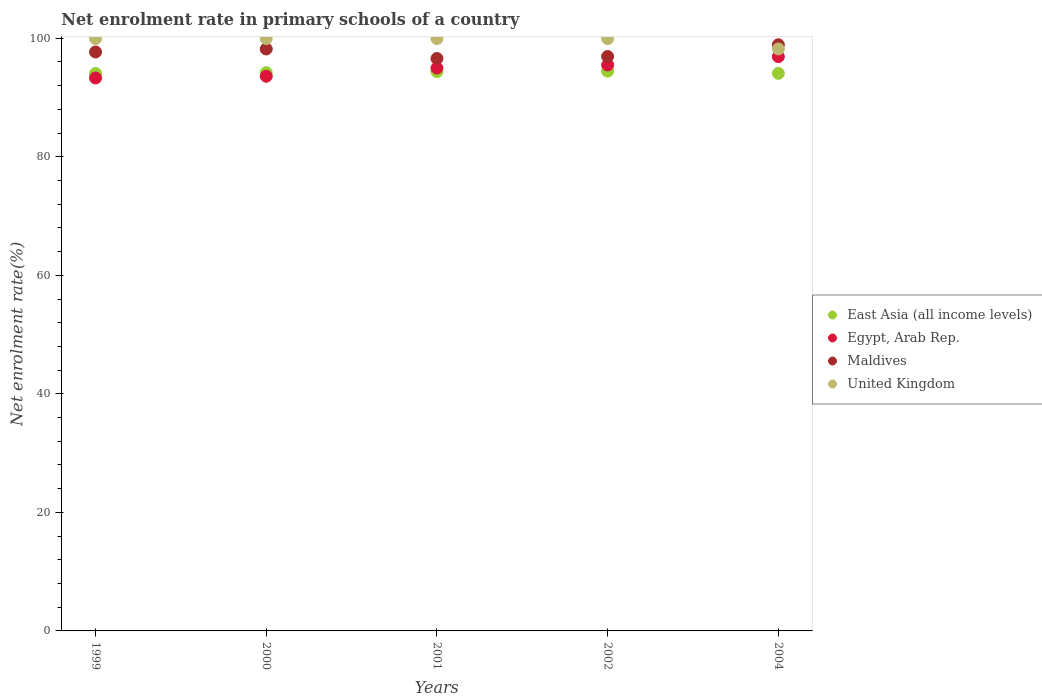Is the number of dotlines equal to the number of legend labels?
Provide a short and direct response. Yes. What is the net enrolment rate in primary schools in East Asia (all income levels) in 2000?
Keep it short and to the point. 94.19. Across all years, what is the maximum net enrolment rate in primary schools in Egypt, Arab Rep.?
Make the answer very short. 96.9. Across all years, what is the minimum net enrolment rate in primary schools in Egypt, Arab Rep.?
Your answer should be compact. 93.3. In which year was the net enrolment rate in primary schools in East Asia (all income levels) minimum?
Ensure brevity in your answer.  1999. What is the total net enrolment rate in primary schools in Egypt, Arab Rep. in the graph?
Ensure brevity in your answer.  474.25. What is the difference between the net enrolment rate in primary schools in Egypt, Arab Rep. in 1999 and that in 2001?
Your answer should be very brief. -1.68. What is the difference between the net enrolment rate in primary schools in United Kingdom in 2004 and the net enrolment rate in primary schools in Egypt, Arab Rep. in 2000?
Ensure brevity in your answer.  4.61. What is the average net enrolment rate in primary schools in Egypt, Arab Rep. per year?
Your answer should be compact. 94.85. In the year 2004, what is the difference between the net enrolment rate in primary schools in Maldives and net enrolment rate in primary schools in Egypt, Arab Rep.?
Provide a succinct answer. 2.01. What is the ratio of the net enrolment rate in primary schools in Maldives in 2000 to that in 2002?
Your answer should be very brief. 1.01. Is the net enrolment rate in primary schools in East Asia (all income levels) in 2000 less than that in 2001?
Ensure brevity in your answer.  Yes. Is the difference between the net enrolment rate in primary schools in Maldives in 1999 and 2002 greater than the difference between the net enrolment rate in primary schools in Egypt, Arab Rep. in 1999 and 2002?
Give a very brief answer. Yes. What is the difference between the highest and the second highest net enrolment rate in primary schools in Maldives?
Keep it short and to the point. 0.71. What is the difference between the highest and the lowest net enrolment rate in primary schools in Maldives?
Make the answer very short. 2.32. In how many years, is the net enrolment rate in primary schools in East Asia (all income levels) greater than the average net enrolment rate in primary schools in East Asia (all income levels) taken over all years?
Your answer should be compact. 2. Is the sum of the net enrolment rate in primary schools in Maldives in 1999 and 2004 greater than the maximum net enrolment rate in primary schools in Egypt, Arab Rep. across all years?
Your answer should be very brief. Yes. Is it the case that in every year, the sum of the net enrolment rate in primary schools in Egypt, Arab Rep. and net enrolment rate in primary schools in East Asia (all income levels)  is greater than the sum of net enrolment rate in primary schools in Maldives and net enrolment rate in primary schools in United Kingdom?
Offer a very short reply. No. Does the net enrolment rate in primary schools in United Kingdom monotonically increase over the years?
Your answer should be compact. No. What is the difference between two consecutive major ticks on the Y-axis?
Give a very brief answer. 20. Are the values on the major ticks of Y-axis written in scientific E-notation?
Provide a short and direct response. No. Where does the legend appear in the graph?
Your response must be concise. Center right. How many legend labels are there?
Your response must be concise. 4. What is the title of the graph?
Offer a very short reply. Net enrolment rate in primary schools of a country. What is the label or title of the X-axis?
Ensure brevity in your answer.  Years. What is the label or title of the Y-axis?
Provide a succinct answer. Net enrolment rate(%). What is the Net enrolment rate(%) of East Asia (all income levels) in 1999?
Offer a terse response. 94.06. What is the Net enrolment rate(%) of Egypt, Arab Rep. in 1999?
Your response must be concise. 93.3. What is the Net enrolment rate(%) of Maldives in 1999?
Your answer should be compact. 97.69. What is the Net enrolment rate(%) in United Kingdom in 1999?
Offer a terse response. 99.95. What is the Net enrolment rate(%) of East Asia (all income levels) in 2000?
Provide a succinct answer. 94.19. What is the Net enrolment rate(%) of Egypt, Arab Rep. in 2000?
Provide a short and direct response. 93.59. What is the Net enrolment rate(%) in Maldives in 2000?
Your answer should be very brief. 98.19. What is the Net enrolment rate(%) of United Kingdom in 2000?
Offer a terse response. 99.95. What is the Net enrolment rate(%) of East Asia (all income levels) in 2001?
Provide a short and direct response. 94.38. What is the Net enrolment rate(%) in Egypt, Arab Rep. in 2001?
Your response must be concise. 94.98. What is the Net enrolment rate(%) in Maldives in 2001?
Your answer should be compact. 96.58. What is the Net enrolment rate(%) of United Kingdom in 2001?
Keep it short and to the point. 99.94. What is the Net enrolment rate(%) in East Asia (all income levels) in 2002?
Offer a terse response. 94.44. What is the Net enrolment rate(%) in Egypt, Arab Rep. in 2002?
Keep it short and to the point. 95.49. What is the Net enrolment rate(%) of Maldives in 2002?
Provide a short and direct response. 96.92. What is the Net enrolment rate(%) of United Kingdom in 2002?
Your answer should be very brief. 99.94. What is the Net enrolment rate(%) in East Asia (all income levels) in 2004?
Your answer should be compact. 94.08. What is the Net enrolment rate(%) in Egypt, Arab Rep. in 2004?
Ensure brevity in your answer.  96.9. What is the Net enrolment rate(%) in Maldives in 2004?
Your answer should be very brief. 98.9. What is the Net enrolment rate(%) of United Kingdom in 2004?
Provide a short and direct response. 98.2. Across all years, what is the maximum Net enrolment rate(%) in East Asia (all income levels)?
Provide a succinct answer. 94.44. Across all years, what is the maximum Net enrolment rate(%) of Egypt, Arab Rep.?
Your answer should be very brief. 96.9. Across all years, what is the maximum Net enrolment rate(%) in Maldives?
Offer a terse response. 98.9. Across all years, what is the maximum Net enrolment rate(%) in United Kingdom?
Provide a succinct answer. 99.95. Across all years, what is the minimum Net enrolment rate(%) of East Asia (all income levels)?
Offer a very short reply. 94.06. Across all years, what is the minimum Net enrolment rate(%) in Egypt, Arab Rep.?
Your answer should be very brief. 93.3. Across all years, what is the minimum Net enrolment rate(%) of Maldives?
Keep it short and to the point. 96.58. Across all years, what is the minimum Net enrolment rate(%) of United Kingdom?
Your answer should be very brief. 98.2. What is the total Net enrolment rate(%) in East Asia (all income levels) in the graph?
Give a very brief answer. 471.15. What is the total Net enrolment rate(%) of Egypt, Arab Rep. in the graph?
Your answer should be compact. 474.25. What is the total Net enrolment rate(%) of Maldives in the graph?
Your response must be concise. 488.28. What is the total Net enrolment rate(%) in United Kingdom in the graph?
Offer a terse response. 497.99. What is the difference between the Net enrolment rate(%) in East Asia (all income levels) in 1999 and that in 2000?
Offer a terse response. -0.14. What is the difference between the Net enrolment rate(%) in Egypt, Arab Rep. in 1999 and that in 2000?
Provide a succinct answer. -0.3. What is the difference between the Net enrolment rate(%) in Maldives in 1999 and that in 2000?
Your answer should be compact. -0.5. What is the difference between the Net enrolment rate(%) in United Kingdom in 1999 and that in 2000?
Ensure brevity in your answer.  -0. What is the difference between the Net enrolment rate(%) in East Asia (all income levels) in 1999 and that in 2001?
Keep it short and to the point. -0.33. What is the difference between the Net enrolment rate(%) of Egypt, Arab Rep. in 1999 and that in 2001?
Keep it short and to the point. -1.68. What is the difference between the Net enrolment rate(%) in Maldives in 1999 and that in 2001?
Give a very brief answer. 1.11. What is the difference between the Net enrolment rate(%) of United Kingdom in 1999 and that in 2001?
Ensure brevity in your answer.  0. What is the difference between the Net enrolment rate(%) in East Asia (all income levels) in 1999 and that in 2002?
Ensure brevity in your answer.  -0.38. What is the difference between the Net enrolment rate(%) of Egypt, Arab Rep. in 1999 and that in 2002?
Provide a succinct answer. -2.2. What is the difference between the Net enrolment rate(%) of Maldives in 1999 and that in 2002?
Ensure brevity in your answer.  0.76. What is the difference between the Net enrolment rate(%) in United Kingdom in 1999 and that in 2002?
Keep it short and to the point. 0.01. What is the difference between the Net enrolment rate(%) of East Asia (all income levels) in 1999 and that in 2004?
Your answer should be very brief. -0.02. What is the difference between the Net enrolment rate(%) of Egypt, Arab Rep. in 1999 and that in 2004?
Your response must be concise. -3.6. What is the difference between the Net enrolment rate(%) in Maldives in 1999 and that in 2004?
Your answer should be very brief. -1.21. What is the difference between the Net enrolment rate(%) in United Kingdom in 1999 and that in 2004?
Provide a succinct answer. 1.75. What is the difference between the Net enrolment rate(%) of East Asia (all income levels) in 2000 and that in 2001?
Offer a very short reply. -0.19. What is the difference between the Net enrolment rate(%) in Egypt, Arab Rep. in 2000 and that in 2001?
Provide a succinct answer. -1.39. What is the difference between the Net enrolment rate(%) of Maldives in 2000 and that in 2001?
Give a very brief answer. 1.61. What is the difference between the Net enrolment rate(%) in United Kingdom in 2000 and that in 2001?
Offer a very short reply. 0.01. What is the difference between the Net enrolment rate(%) in East Asia (all income levels) in 2000 and that in 2002?
Make the answer very short. -0.25. What is the difference between the Net enrolment rate(%) in Egypt, Arab Rep. in 2000 and that in 2002?
Offer a very short reply. -1.9. What is the difference between the Net enrolment rate(%) in Maldives in 2000 and that in 2002?
Your answer should be compact. 1.26. What is the difference between the Net enrolment rate(%) in United Kingdom in 2000 and that in 2002?
Provide a short and direct response. 0.01. What is the difference between the Net enrolment rate(%) of East Asia (all income levels) in 2000 and that in 2004?
Offer a terse response. 0.12. What is the difference between the Net enrolment rate(%) in Egypt, Arab Rep. in 2000 and that in 2004?
Provide a succinct answer. -3.31. What is the difference between the Net enrolment rate(%) in Maldives in 2000 and that in 2004?
Keep it short and to the point. -0.71. What is the difference between the Net enrolment rate(%) of United Kingdom in 2000 and that in 2004?
Make the answer very short. 1.75. What is the difference between the Net enrolment rate(%) of East Asia (all income levels) in 2001 and that in 2002?
Offer a terse response. -0.06. What is the difference between the Net enrolment rate(%) in Egypt, Arab Rep. in 2001 and that in 2002?
Provide a succinct answer. -0.52. What is the difference between the Net enrolment rate(%) in Maldives in 2001 and that in 2002?
Ensure brevity in your answer.  -0.34. What is the difference between the Net enrolment rate(%) of United Kingdom in 2001 and that in 2002?
Your answer should be very brief. 0. What is the difference between the Net enrolment rate(%) in East Asia (all income levels) in 2001 and that in 2004?
Ensure brevity in your answer.  0.31. What is the difference between the Net enrolment rate(%) in Egypt, Arab Rep. in 2001 and that in 2004?
Make the answer very short. -1.92. What is the difference between the Net enrolment rate(%) in Maldives in 2001 and that in 2004?
Make the answer very short. -2.32. What is the difference between the Net enrolment rate(%) in United Kingdom in 2001 and that in 2004?
Offer a terse response. 1.74. What is the difference between the Net enrolment rate(%) in East Asia (all income levels) in 2002 and that in 2004?
Ensure brevity in your answer.  0.36. What is the difference between the Net enrolment rate(%) of Egypt, Arab Rep. in 2002 and that in 2004?
Your answer should be very brief. -1.4. What is the difference between the Net enrolment rate(%) of Maldives in 2002 and that in 2004?
Your response must be concise. -1.98. What is the difference between the Net enrolment rate(%) in United Kingdom in 2002 and that in 2004?
Provide a short and direct response. 1.74. What is the difference between the Net enrolment rate(%) in East Asia (all income levels) in 1999 and the Net enrolment rate(%) in Egypt, Arab Rep. in 2000?
Your response must be concise. 0.46. What is the difference between the Net enrolment rate(%) of East Asia (all income levels) in 1999 and the Net enrolment rate(%) of Maldives in 2000?
Your answer should be very brief. -4.13. What is the difference between the Net enrolment rate(%) in East Asia (all income levels) in 1999 and the Net enrolment rate(%) in United Kingdom in 2000?
Offer a terse response. -5.9. What is the difference between the Net enrolment rate(%) of Egypt, Arab Rep. in 1999 and the Net enrolment rate(%) of Maldives in 2000?
Keep it short and to the point. -4.89. What is the difference between the Net enrolment rate(%) in Egypt, Arab Rep. in 1999 and the Net enrolment rate(%) in United Kingdom in 2000?
Keep it short and to the point. -6.66. What is the difference between the Net enrolment rate(%) of Maldives in 1999 and the Net enrolment rate(%) of United Kingdom in 2000?
Offer a very short reply. -2.26. What is the difference between the Net enrolment rate(%) in East Asia (all income levels) in 1999 and the Net enrolment rate(%) in Egypt, Arab Rep. in 2001?
Provide a short and direct response. -0.92. What is the difference between the Net enrolment rate(%) in East Asia (all income levels) in 1999 and the Net enrolment rate(%) in Maldives in 2001?
Provide a succinct answer. -2.53. What is the difference between the Net enrolment rate(%) in East Asia (all income levels) in 1999 and the Net enrolment rate(%) in United Kingdom in 2001?
Provide a succinct answer. -5.89. What is the difference between the Net enrolment rate(%) of Egypt, Arab Rep. in 1999 and the Net enrolment rate(%) of Maldives in 2001?
Offer a very short reply. -3.29. What is the difference between the Net enrolment rate(%) of Egypt, Arab Rep. in 1999 and the Net enrolment rate(%) of United Kingdom in 2001?
Offer a terse response. -6.65. What is the difference between the Net enrolment rate(%) in Maldives in 1999 and the Net enrolment rate(%) in United Kingdom in 2001?
Provide a short and direct response. -2.26. What is the difference between the Net enrolment rate(%) of East Asia (all income levels) in 1999 and the Net enrolment rate(%) of Egypt, Arab Rep. in 2002?
Keep it short and to the point. -1.44. What is the difference between the Net enrolment rate(%) of East Asia (all income levels) in 1999 and the Net enrolment rate(%) of Maldives in 2002?
Your answer should be compact. -2.87. What is the difference between the Net enrolment rate(%) of East Asia (all income levels) in 1999 and the Net enrolment rate(%) of United Kingdom in 2002?
Ensure brevity in your answer.  -5.89. What is the difference between the Net enrolment rate(%) in Egypt, Arab Rep. in 1999 and the Net enrolment rate(%) in Maldives in 2002?
Offer a very short reply. -3.63. What is the difference between the Net enrolment rate(%) in Egypt, Arab Rep. in 1999 and the Net enrolment rate(%) in United Kingdom in 2002?
Provide a succinct answer. -6.65. What is the difference between the Net enrolment rate(%) of Maldives in 1999 and the Net enrolment rate(%) of United Kingdom in 2002?
Offer a terse response. -2.25. What is the difference between the Net enrolment rate(%) in East Asia (all income levels) in 1999 and the Net enrolment rate(%) in Egypt, Arab Rep. in 2004?
Keep it short and to the point. -2.84. What is the difference between the Net enrolment rate(%) of East Asia (all income levels) in 1999 and the Net enrolment rate(%) of Maldives in 2004?
Your answer should be compact. -4.85. What is the difference between the Net enrolment rate(%) in East Asia (all income levels) in 1999 and the Net enrolment rate(%) in United Kingdom in 2004?
Make the answer very short. -4.14. What is the difference between the Net enrolment rate(%) of Egypt, Arab Rep. in 1999 and the Net enrolment rate(%) of Maldives in 2004?
Offer a very short reply. -5.61. What is the difference between the Net enrolment rate(%) of Egypt, Arab Rep. in 1999 and the Net enrolment rate(%) of United Kingdom in 2004?
Your answer should be very brief. -4.9. What is the difference between the Net enrolment rate(%) in Maldives in 1999 and the Net enrolment rate(%) in United Kingdom in 2004?
Your response must be concise. -0.51. What is the difference between the Net enrolment rate(%) in East Asia (all income levels) in 2000 and the Net enrolment rate(%) in Egypt, Arab Rep. in 2001?
Keep it short and to the point. -0.78. What is the difference between the Net enrolment rate(%) of East Asia (all income levels) in 2000 and the Net enrolment rate(%) of Maldives in 2001?
Offer a terse response. -2.39. What is the difference between the Net enrolment rate(%) of East Asia (all income levels) in 2000 and the Net enrolment rate(%) of United Kingdom in 2001?
Offer a terse response. -5.75. What is the difference between the Net enrolment rate(%) of Egypt, Arab Rep. in 2000 and the Net enrolment rate(%) of Maldives in 2001?
Your response must be concise. -2.99. What is the difference between the Net enrolment rate(%) in Egypt, Arab Rep. in 2000 and the Net enrolment rate(%) in United Kingdom in 2001?
Your answer should be compact. -6.35. What is the difference between the Net enrolment rate(%) of Maldives in 2000 and the Net enrolment rate(%) of United Kingdom in 2001?
Provide a succinct answer. -1.76. What is the difference between the Net enrolment rate(%) of East Asia (all income levels) in 2000 and the Net enrolment rate(%) of Egypt, Arab Rep. in 2002?
Offer a very short reply. -1.3. What is the difference between the Net enrolment rate(%) in East Asia (all income levels) in 2000 and the Net enrolment rate(%) in Maldives in 2002?
Ensure brevity in your answer.  -2.73. What is the difference between the Net enrolment rate(%) in East Asia (all income levels) in 2000 and the Net enrolment rate(%) in United Kingdom in 2002?
Provide a short and direct response. -5.75. What is the difference between the Net enrolment rate(%) in Egypt, Arab Rep. in 2000 and the Net enrolment rate(%) in Maldives in 2002?
Offer a terse response. -3.33. What is the difference between the Net enrolment rate(%) in Egypt, Arab Rep. in 2000 and the Net enrolment rate(%) in United Kingdom in 2002?
Make the answer very short. -6.35. What is the difference between the Net enrolment rate(%) in Maldives in 2000 and the Net enrolment rate(%) in United Kingdom in 2002?
Make the answer very short. -1.76. What is the difference between the Net enrolment rate(%) in East Asia (all income levels) in 2000 and the Net enrolment rate(%) in Egypt, Arab Rep. in 2004?
Ensure brevity in your answer.  -2.7. What is the difference between the Net enrolment rate(%) in East Asia (all income levels) in 2000 and the Net enrolment rate(%) in Maldives in 2004?
Your answer should be compact. -4.71. What is the difference between the Net enrolment rate(%) in East Asia (all income levels) in 2000 and the Net enrolment rate(%) in United Kingdom in 2004?
Provide a short and direct response. -4.01. What is the difference between the Net enrolment rate(%) of Egypt, Arab Rep. in 2000 and the Net enrolment rate(%) of Maldives in 2004?
Your answer should be very brief. -5.31. What is the difference between the Net enrolment rate(%) of Egypt, Arab Rep. in 2000 and the Net enrolment rate(%) of United Kingdom in 2004?
Provide a succinct answer. -4.61. What is the difference between the Net enrolment rate(%) of Maldives in 2000 and the Net enrolment rate(%) of United Kingdom in 2004?
Your response must be concise. -0.01. What is the difference between the Net enrolment rate(%) of East Asia (all income levels) in 2001 and the Net enrolment rate(%) of Egypt, Arab Rep. in 2002?
Make the answer very short. -1.11. What is the difference between the Net enrolment rate(%) in East Asia (all income levels) in 2001 and the Net enrolment rate(%) in Maldives in 2002?
Your answer should be very brief. -2.54. What is the difference between the Net enrolment rate(%) of East Asia (all income levels) in 2001 and the Net enrolment rate(%) of United Kingdom in 2002?
Provide a succinct answer. -5.56. What is the difference between the Net enrolment rate(%) in Egypt, Arab Rep. in 2001 and the Net enrolment rate(%) in Maldives in 2002?
Offer a terse response. -1.95. What is the difference between the Net enrolment rate(%) of Egypt, Arab Rep. in 2001 and the Net enrolment rate(%) of United Kingdom in 2002?
Provide a short and direct response. -4.97. What is the difference between the Net enrolment rate(%) of Maldives in 2001 and the Net enrolment rate(%) of United Kingdom in 2002?
Offer a terse response. -3.36. What is the difference between the Net enrolment rate(%) in East Asia (all income levels) in 2001 and the Net enrolment rate(%) in Egypt, Arab Rep. in 2004?
Ensure brevity in your answer.  -2.52. What is the difference between the Net enrolment rate(%) in East Asia (all income levels) in 2001 and the Net enrolment rate(%) in Maldives in 2004?
Offer a very short reply. -4.52. What is the difference between the Net enrolment rate(%) in East Asia (all income levels) in 2001 and the Net enrolment rate(%) in United Kingdom in 2004?
Provide a succinct answer. -3.82. What is the difference between the Net enrolment rate(%) of Egypt, Arab Rep. in 2001 and the Net enrolment rate(%) of Maldives in 2004?
Offer a very short reply. -3.93. What is the difference between the Net enrolment rate(%) in Egypt, Arab Rep. in 2001 and the Net enrolment rate(%) in United Kingdom in 2004?
Give a very brief answer. -3.22. What is the difference between the Net enrolment rate(%) in Maldives in 2001 and the Net enrolment rate(%) in United Kingdom in 2004?
Give a very brief answer. -1.62. What is the difference between the Net enrolment rate(%) of East Asia (all income levels) in 2002 and the Net enrolment rate(%) of Egypt, Arab Rep. in 2004?
Your answer should be very brief. -2.46. What is the difference between the Net enrolment rate(%) in East Asia (all income levels) in 2002 and the Net enrolment rate(%) in Maldives in 2004?
Your answer should be compact. -4.46. What is the difference between the Net enrolment rate(%) of East Asia (all income levels) in 2002 and the Net enrolment rate(%) of United Kingdom in 2004?
Your answer should be compact. -3.76. What is the difference between the Net enrolment rate(%) in Egypt, Arab Rep. in 2002 and the Net enrolment rate(%) in Maldives in 2004?
Your response must be concise. -3.41. What is the difference between the Net enrolment rate(%) of Egypt, Arab Rep. in 2002 and the Net enrolment rate(%) of United Kingdom in 2004?
Ensure brevity in your answer.  -2.71. What is the difference between the Net enrolment rate(%) of Maldives in 2002 and the Net enrolment rate(%) of United Kingdom in 2004?
Provide a short and direct response. -1.28. What is the average Net enrolment rate(%) of East Asia (all income levels) per year?
Your answer should be very brief. 94.23. What is the average Net enrolment rate(%) in Egypt, Arab Rep. per year?
Your answer should be very brief. 94.85. What is the average Net enrolment rate(%) of Maldives per year?
Ensure brevity in your answer.  97.66. What is the average Net enrolment rate(%) in United Kingdom per year?
Give a very brief answer. 99.6. In the year 1999, what is the difference between the Net enrolment rate(%) of East Asia (all income levels) and Net enrolment rate(%) of Egypt, Arab Rep.?
Give a very brief answer. 0.76. In the year 1999, what is the difference between the Net enrolment rate(%) in East Asia (all income levels) and Net enrolment rate(%) in Maldives?
Provide a succinct answer. -3.63. In the year 1999, what is the difference between the Net enrolment rate(%) of East Asia (all income levels) and Net enrolment rate(%) of United Kingdom?
Ensure brevity in your answer.  -5.89. In the year 1999, what is the difference between the Net enrolment rate(%) of Egypt, Arab Rep. and Net enrolment rate(%) of Maldives?
Keep it short and to the point. -4.39. In the year 1999, what is the difference between the Net enrolment rate(%) of Egypt, Arab Rep. and Net enrolment rate(%) of United Kingdom?
Your answer should be compact. -6.65. In the year 1999, what is the difference between the Net enrolment rate(%) in Maldives and Net enrolment rate(%) in United Kingdom?
Your answer should be very brief. -2.26. In the year 2000, what is the difference between the Net enrolment rate(%) in East Asia (all income levels) and Net enrolment rate(%) in Egypt, Arab Rep.?
Provide a short and direct response. 0.6. In the year 2000, what is the difference between the Net enrolment rate(%) in East Asia (all income levels) and Net enrolment rate(%) in Maldives?
Offer a very short reply. -3.99. In the year 2000, what is the difference between the Net enrolment rate(%) of East Asia (all income levels) and Net enrolment rate(%) of United Kingdom?
Ensure brevity in your answer.  -5.76. In the year 2000, what is the difference between the Net enrolment rate(%) in Egypt, Arab Rep. and Net enrolment rate(%) in Maldives?
Your answer should be compact. -4.6. In the year 2000, what is the difference between the Net enrolment rate(%) of Egypt, Arab Rep. and Net enrolment rate(%) of United Kingdom?
Make the answer very short. -6.36. In the year 2000, what is the difference between the Net enrolment rate(%) of Maldives and Net enrolment rate(%) of United Kingdom?
Offer a terse response. -1.76. In the year 2001, what is the difference between the Net enrolment rate(%) in East Asia (all income levels) and Net enrolment rate(%) in Egypt, Arab Rep.?
Keep it short and to the point. -0.59. In the year 2001, what is the difference between the Net enrolment rate(%) of East Asia (all income levels) and Net enrolment rate(%) of Maldives?
Make the answer very short. -2.2. In the year 2001, what is the difference between the Net enrolment rate(%) of East Asia (all income levels) and Net enrolment rate(%) of United Kingdom?
Your response must be concise. -5.56. In the year 2001, what is the difference between the Net enrolment rate(%) in Egypt, Arab Rep. and Net enrolment rate(%) in Maldives?
Provide a succinct answer. -1.61. In the year 2001, what is the difference between the Net enrolment rate(%) in Egypt, Arab Rep. and Net enrolment rate(%) in United Kingdom?
Your answer should be very brief. -4.97. In the year 2001, what is the difference between the Net enrolment rate(%) in Maldives and Net enrolment rate(%) in United Kingdom?
Your response must be concise. -3.36. In the year 2002, what is the difference between the Net enrolment rate(%) in East Asia (all income levels) and Net enrolment rate(%) in Egypt, Arab Rep.?
Ensure brevity in your answer.  -1.05. In the year 2002, what is the difference between the Net enrolment rate(%) in East Asia (all income levels) and Net enrolment rate(%) in Maldives?
Give a very brief answer. -2.48. In the year 2002, what is the difference between the Net enrolment rate(%) in East Asia (all income levels) and Net enrolment rate(%) in United Kingdom?
Ensure brevity in your answer.  -5.5. In the year 2002, what is the difference between the Net enrolment rate(%) of Egypt, Arab Rep. and Net enrolment rate(%) of Maldives?
Provide a succinct answer. -1.43. In the year 2002, what is the difference between the Net enrolment rate(%) in Egypt, Arab Rep. and Net enrolment rate(%) in United Kingdom?
Your response must be concise. -4.45. In the year 2002, what is the difference between the Net enrolment rate(%) of Maldives and Net enrolment rate(%) of United Kingdom?
Your answer should be very brief. -3.02. In the year 2004, what is the difference between the Net enrolment rate(%) of East Asia (all income levels) and Net enrolment rate(%) of Egypt, Arab Rep.?
Ensure brevity in your answer.  -2.82. In the year 2004, what is the difference between the Net enrolment rate(%) in East Asia (all income levels) and Net enrolment rate(%) in Maldives?
Provide a succinct answer. -4.83. In the year 2004, what is the difference between the Net enrolment rate(%) of East Asia (all income levels) and Net enrolment rate(%) of United Kingdom?
Keep it short and to the point. -4.12. In the year 2004, what is the difference between the Net enrolment rate(%) of Egypt, Arab Rep. and Net enrolment rate(%) of Maldives?
Give a very brief answer. -2.01. In the year 2004, what is the difference between the Net enrolment rate(%) of Egypt, Arab Rep. and Net enrolment rate(%) of United Kingdom?
Provide a short and direct response. -1.3. In the year 2004, what is the difference between the Net enrolment rate(%) in Maldives and Net enrolment rate(%) in United Kingdom?
Offer a terse response. 0.7. What is the ratio of the Net enrolment rate(%) of East Asia (all income levels) in 1999 to that in 2001?
Keep it short and to the point. 1. What is the ratio of the Net enrolment rate(%) of Egypt, Arab Rep. in 1999 to that in 2001?
Offer a very short reply. 0.98. What is the ratio of the Net enrolment rate(%) of Maldives in 1999 to that in 2001?
Provide a succinct answer. 1.01. What is the ratio of the Net enrolment rate(%) of United Kingdom in 1999 to that in 2001?
Offer a very short reply. 1. What is the ratio of the Net enrolment rate(%) in East Asia (all income levels) in 1999 to that in 2002?
Provide a succinct answer. 1. What is the ratio of the Net enrolment rate(%) of Maldives in 1999 to that in 2002?
Provide a short and direct response. 1.01. What is the ratio of the Net enrolment rate(%) in East Asia (all income levels) in 1999 to that in 2004?
Give a very brief answer. 1. What is the ratio of the Net enrolment rate(%) of Egypt, Arab Rep. in 1999 to that in 2004?
Your answer should be very brief. 0.96. What is the ratio of the Net enrolment rate(%) in United Kingdom in 1999 to that in 2004?
Provide a short and direct response. 1.02. What is the ratio of the Net enrolment rate(%) in East Asia (all income levels) in 2000 to that in 2001?
Your answer should be compact. 1. What is the ratio of the Net enrolment rate(%) in Egypt, Arab Rep. in 2000 to that in 2001?
Give a very brief answer. 0.99. What is the ratio of the Net enrolment rate(%) in Maldives in 2000 to that in 2001?
Your response must be concise. 1.02. What is the ratio of the Net enrolment rate(%) of United Kingdom in 2000 to that in 2001?
Provide a short and direct response. 1. What is the ratio of the Net enrolment rate(%) in East Asia (all income levels) in 2000 to that in 2002?
Your answer should be very brief. 1. What is the ratio of the Net enrolment rate(%) in Egypt, Arab Rep. in 2000 to that in 2002?
Your response must be concise. 0.98. What is the ratio of the Net enrolment rate(%) of United Kingdom in 2000 to that in 2002?
Provide a short and direct response. 1. What is the ratio of the Net enrolment rate(%) of East Asia (all income levels) in 2000 to that in 2004?
Offer a very short reply. 1. What is the ratio of the Net enrolment rate(%) in Egypt, Arab Rep. in 2000 to that in 2004?
Your answer should be very brief. 0.97. What is the ratio of the Net enrolment rate(%) of United Kingdom in 2000 to that in 2004?
Your answer should be very brief. 1.02. What is the ratio of the Net enrolment rate(%) in East Asia (all income levels) in 2001 to that in 2002?
Offer a terse response. 1. What is the ratio of the Net enrolment rate(%) of Egypt, Arab Rep. in 2001 to that in 2002?
Provide a succinct answer. 0.99. What is the ratio of the Net enrolment rate(%) of Maldives in 2001 to that in 2002?
Your answer should be very brief. 1. What is the ratio of the Net enrolment rate(%) in East Asia (all income levels) in 2001 to that in 2004?
Offer a terse response. 1. What is the ratio of the Net enrolment rate(%) of Egypt, Arab Rep. in 2001 to that in 2004?
Provide a short and direct response. 0.98. What is the ratio of the Net enrolment rate(%) in Maldives in 2001 to that in 2004?
Keep it short and to the point. 0.98. What is the ratio of the Net enrolment rate(%) of United Kingdom in 2001 to that in 2004?
Provide a short and direct response. 1.02. What is the ratio of the Net enrolment rate(%) of Egypt, Arab Rep. in 2002 to that in 2004?
Ensure brevity in your answer.  0.99. What is the ratio of the Net enrolment rate(%) in United Kingdom in 2002 to that in 2004?
Your answer should be compact. 1.02. What is the difference between the highest and the second highest Net enrolment rate(%) of East Asia (all income levels)?
Provide a short and direct response. 0.06. What is the difference between the highest and the second highest Net enrolment rate(%) in Egypt, Arab Rep.?
Your response must be concise. 1.4. What is the difference between the highest and the second highest Net enrolment rate(%) in Maldives?
Your answer should be compact. 0.71. What is the difference between the highest and the second highest Net enrolment rate(%) of United Kingdom?
Ensure brevity in your answer.  0. What is the difference between the highest and the lowest Net enrolment rate(%) in East Asia (all income levels)?
Your answer should be compact. 0.38. What is the difference between the highest and the lowest Net enrolment rate(%) in Egypt, Arab Rep.?
Provide a short and direct response. 3.6. What is the difference between the highest and the lowest Net enrolment rate(%) in Maldives?
Your answer should be compact. 2.32. What is the difference between the highest and the lowest Net enrolment rate(%) of United Kingdom?
Make the answer very short. 1.75. 